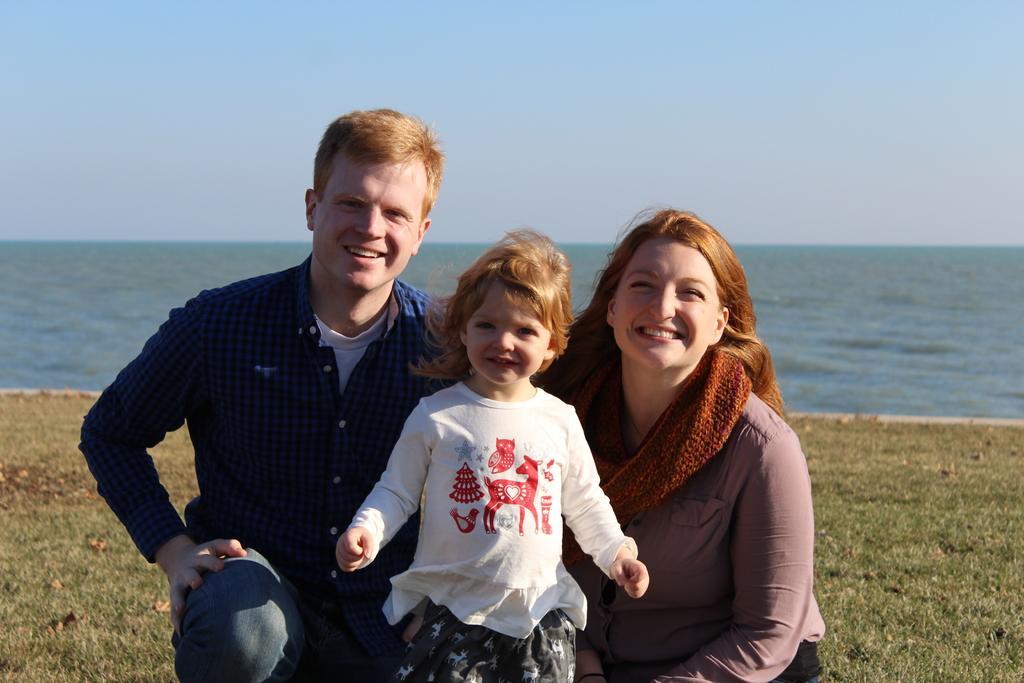Could you give a brief overview of what you see in this image? In the foreground of this image, there is a man and a woman squatting on the grass and a girl standing and posing to the camera. In the background, there is water and the sky. 